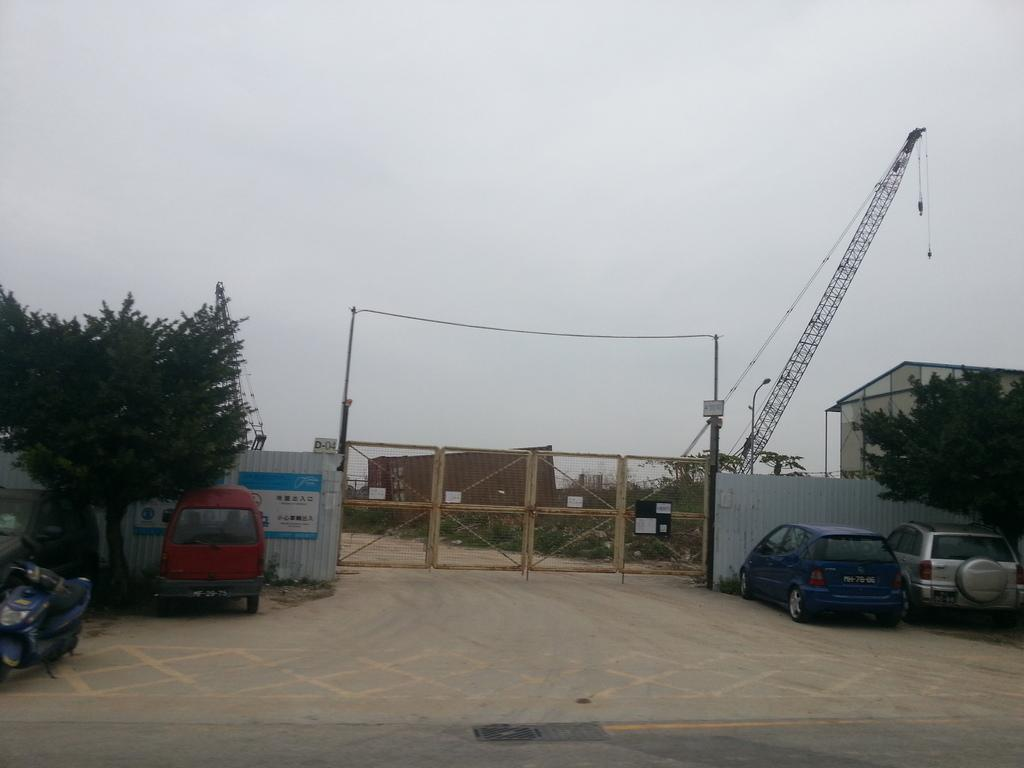What type of natural elements can be seen in the image? There are trees in the image. What is happening in front of the gate in the image? There are vehicles in front of a gate in the image. What type of structure can be seen in the background of the image? There is a building in the background of the image. What objects are present in the background of the image? There is a container and a crane in the background of the image. How many children are playing in the crowd in the image? There is no crowd or children present in the image. What type of step is visible in the image? There is no step visible in the image. 